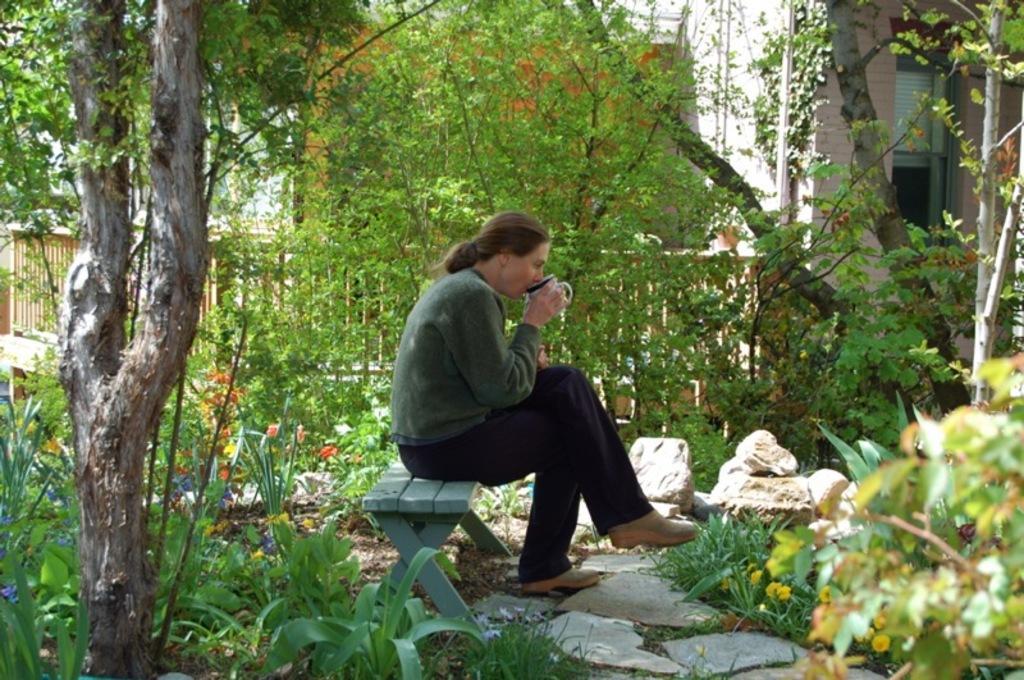Describe this image in one or two sentences. In this image I can see the person is holding the cup and sitting on the bench. Back I can see few trees, building, fencing and few stones. 